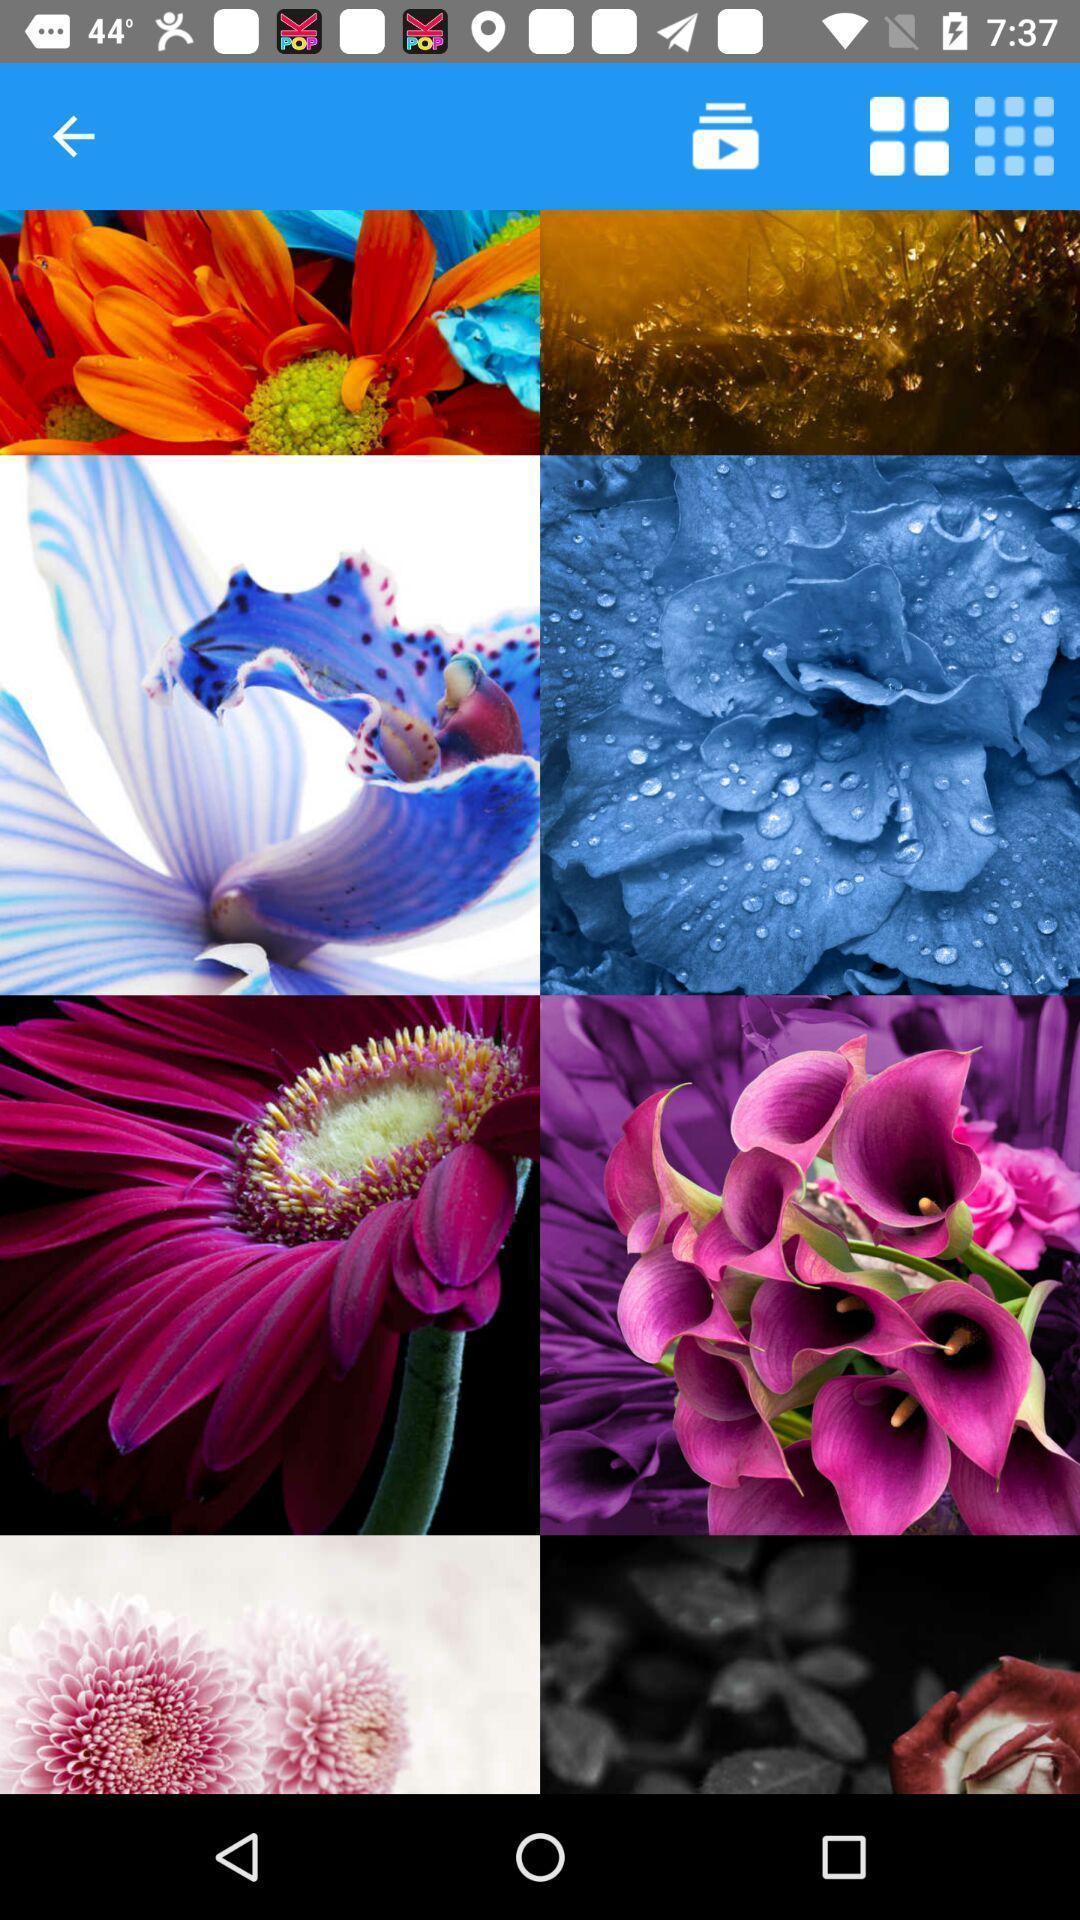Provide a description of this screenshot. Screen displaying different wallpapers. 